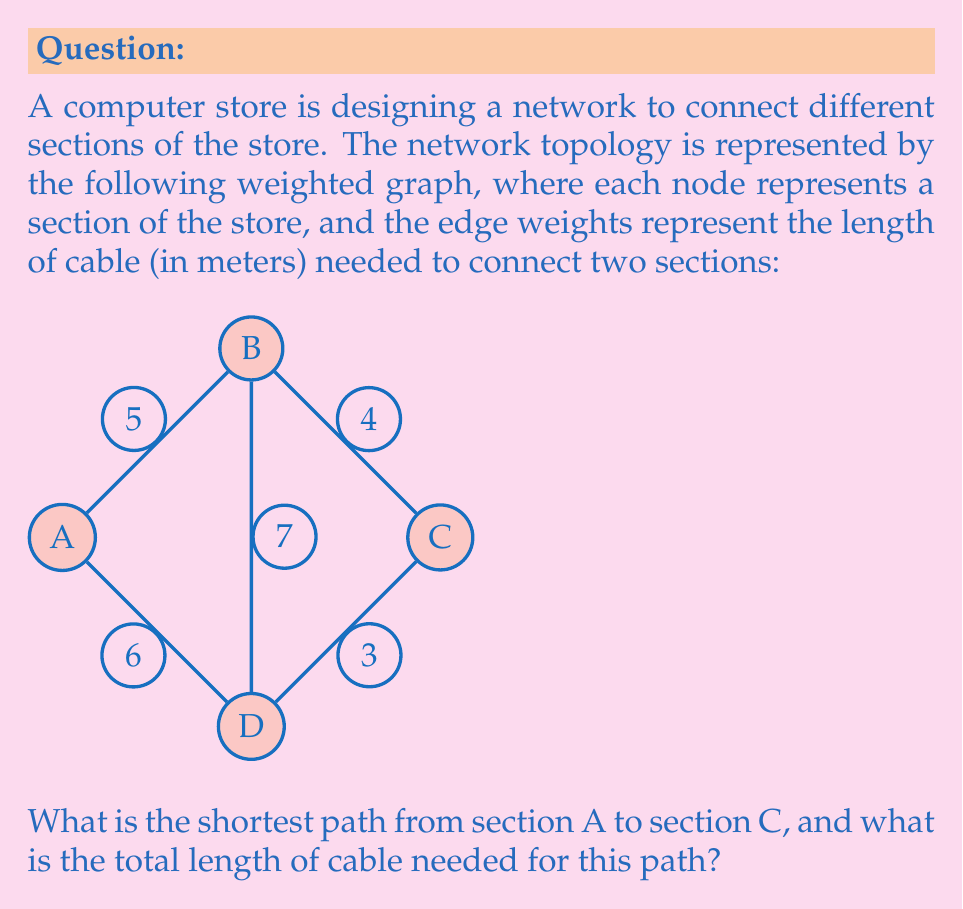Can you answer this question? To solve this problem, we can use Dijkstra's algorithm to find the shortest path from A to C. Let's go through the steps:

1) Initialize:
   - Distance to A: 0
   - Distance to B, C, D: $\infty$
   - Unvisited set: {A, B, C, D}

2) Start from A:
   - Update distances: A->B (5), A->D (6)
   - Mark A as visited
   - Unvisited set: {B, C, D}

3) Choose B (shortest distance from A):
   - Update distances: B->C (5+4=9), B->D (5+7=12)
   - Mark B as visited
   - Unvisited set: {C, D}

4) Choose D (shortest distance from A):
   - Update distances: D->C (6+3=9)
   - Mark D as visited
   - Unvisited set: {C}

5) Choose C (only remaining node):
   - Mark C as visited
   - Algorithm complete

The shortest path from A to C is A->B->C with a total distance of 9 meters.

We can verify this:
- A->B->C = 5 + 4 = 9 meters
- A->D->C = 6 + 3 = 9 meters

Both paths have the same length, so either could be considered the shortest path. However, the question asks for a single path, so we'll stick with A->B->C.
Answer: The shortest path from A to C is A->B->C, with a total cable length of 9 meters. 